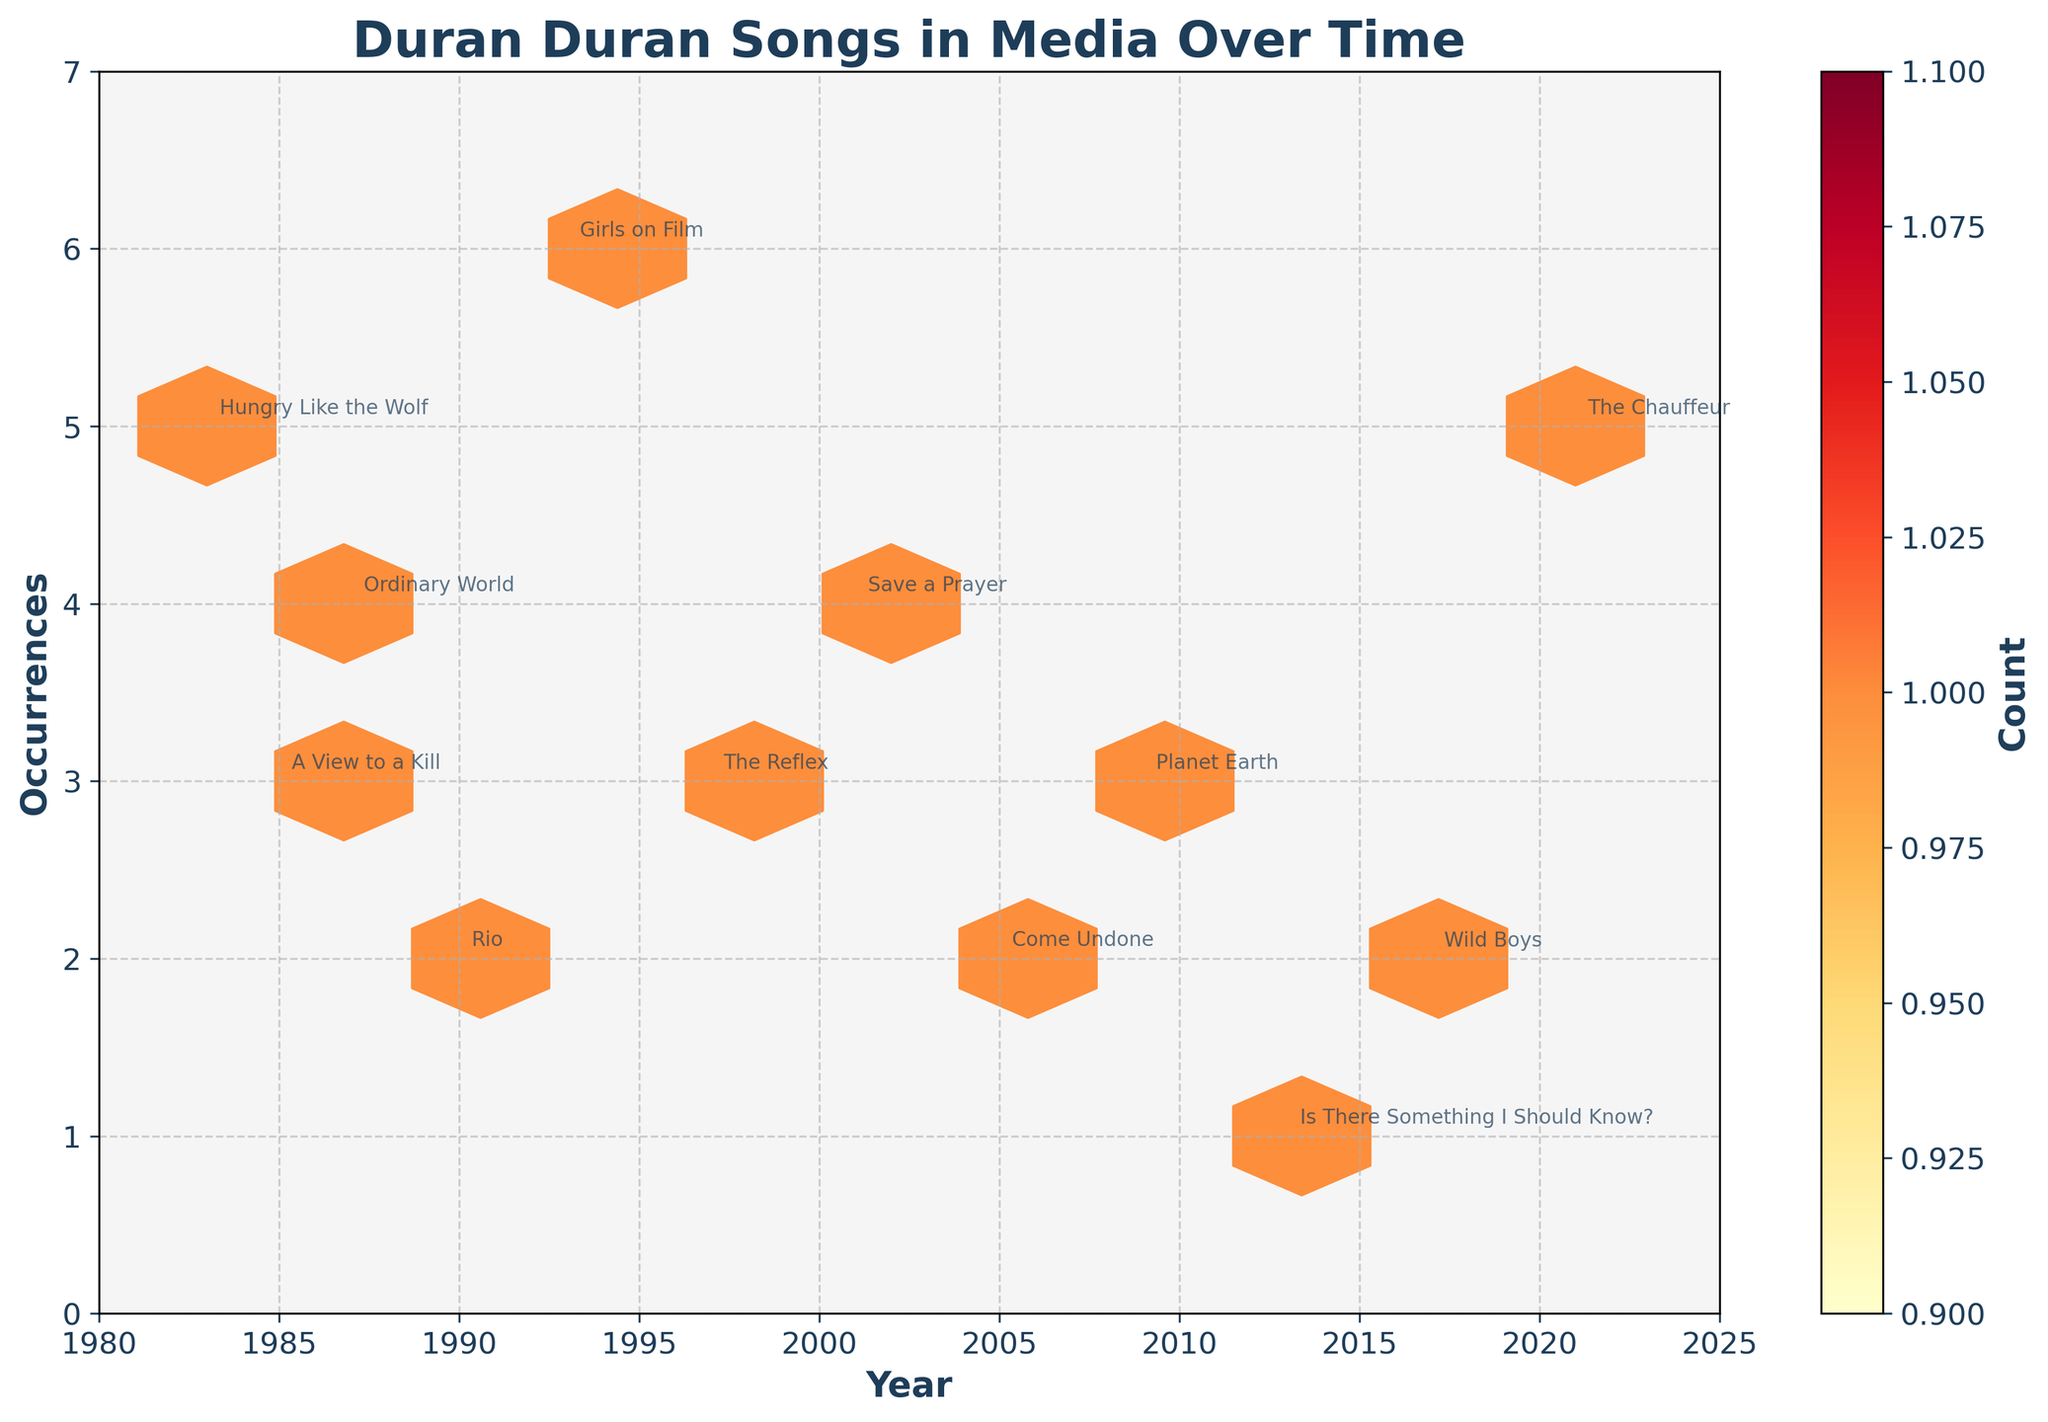What's the title of the figure? The title is displayed at the top of the figure. It reads "Duran Duran Songs in Media Over Time."
Answer: Duran Duran Songs in Media Over Time What is the x-axis labeled? The x-axis label is visible underneath the axis. It reads "Year."
Answer: Year What is the y-axis labeled? The y-axis label is visible along the left side of the axis. It reads "Occurrences."
Answer: Occurrences What color is used for the hexagons in the plot? The hexagons are filled with varying shades of a yellow-orange-red gradient.
Answer: Yellow-orange-red gradient What is the highest number of occurrences for any Duran Duran song in the figure, and in which year did it occur? To determine this, locate the highest point on the y-axis where a song appears. Visually follow it to the corresponding year on the x-axis. The highest value on the y-axis is 6, occurring in the year 1993.
Answer: 6 in 1993 How many years have exactly 3 occurrences of Duran Duran songs? By observing the y-axis value of 3, count the individual years along the x-axis that intersect with 3 occurrences. These years are 1985, 1997, and 2009.
Answer: 3 years (1985, 1997, 2009) Which song has more occurrences in a single year: "Girls on Film" or "Planet Earth"? Identify the occurrences of each song by following their annotations to the y-axis. "Girls on Film" has 6 occurrences in 1993, while "Planet Earth" has 3 occurrences in 2009.
Answer: Girls on Film Which year has more occurrences of Duran Duran songs: 1983 or 2005? Check the occurrences in the years 1983 and 2005 by finding the y-values corresponding to these years. 1983 has 5 occurrences, and 2005 has 2 occurrences.
Answer: 1983 Did any Duran Duran song have more than 5 occurrences in a year? Look at the y-axis for occurrences higher than 5 and check the corresponding song annotations. Only "Girls on Film" in 1993 has 6 occurrences, which is more than 5.
Answer: Yes In which grid cell are the most Duran Duran songs grouped together, and how many are there? The hexbin plot groups occurrences into hexagonal bins. The cell with the darkest shade indicates the most occurrences. Since the color bar shows a "Count" label, the darkest cell represents the highest count. In this plot, no hexbin has multiple overlaps due to the limited data points, each cell represents single instances only.
Answer: No group with more than 1 song 